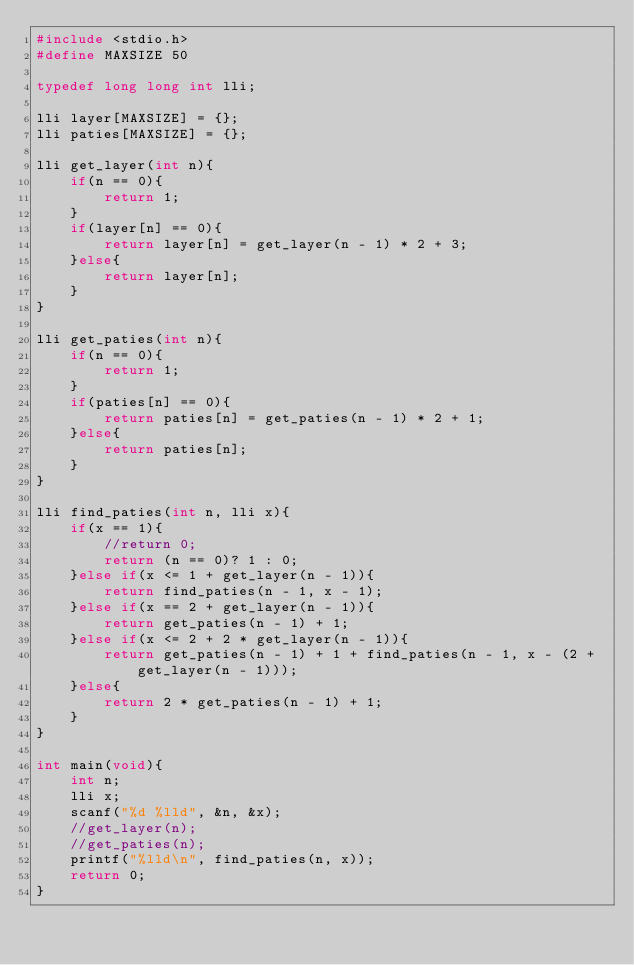<code> <loc_0><loc_0><loc_500><loc_500><_C_>#include <stdio.h>
#define MAXSIZE 50

typedef long long int lli;

lli layer[MAXSIZE] = {};
lli paties[MAXSIZE] = {};

lli get_layer(int n){
    if(n == 0){
        return 1;
    }
    if(layer[n] == 0){
        return layer[n] = get_layer(n - 1) * 2 + 3;
    }else{
        return layer[n];
    }
}

lli get_paties(int n){
    if(n == 0){
        return 1;
    }
    if(paties[n] == 0){
        return paties[n] = get_paties(n - 1) * 2 + 1;
    }else{
        return paties[n];
    }
}

lli find_paties(int n, lli x){
    if(x == 1){
        //return 0;
        return (n == 0)? 1 : 0;
    }else if(x <= 1 + get_layer(n - 1)){
        return find_paties(n - 1, x - 1);
    }else if(x == 2 + get_layer(n - 1)){
        return get_paties(n - 1) + 1;
    }else if(x <= 2 + 2 * get_layer(n - 1)){
        return get_paties(n - 1) + 1 + find_paties(n - 1, x - (2 + get_layer(n - 1)));
    }else{
        return 2 * get_paties(n - 1) + 1;
    }
}

int main(void){
    int n;
    lli x;
    scanf("%d %lld", &n, &x);
    //get_layer(n);
    //get_paties(n);
    printf("%lld\n", find_paties(n, x));
    return 0;
}</code> 